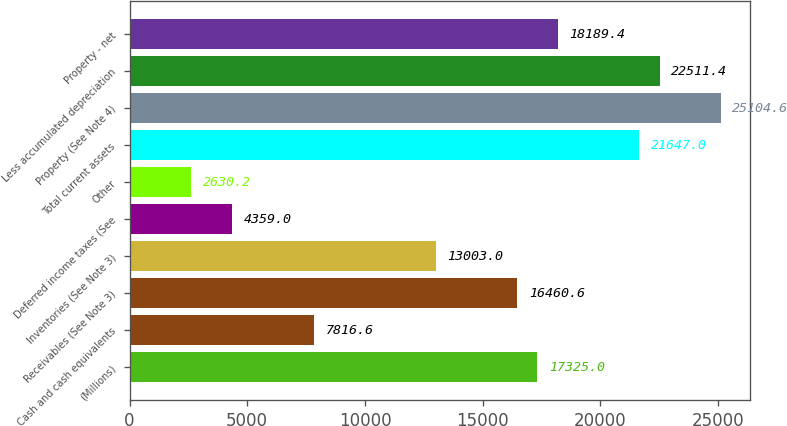Convert chart to OTSL. <chart><loc_0><loc_0><loc_500><loc_500><bar_chart><fcel>(Millions)<fcel>Cash and cash equivalents<fcel>Receivables (See Note 3)<fcel>Inventories (See Note 3)<fcel>Deferred income taxes (See<fcel>Other<fcel>Total current assets<fcel>Property (See Note 4)<fcel>Less accumulated depreciation<fcel>Property - net<nl><fcel>17325<fcel>7816.6<fcel>16460.6<fcel>13003<fcel>4359<fcel>2630.2<fcel>21647<fcel>25104.6<fcel>22511.4<fcel>18189.4<nl></chart> 